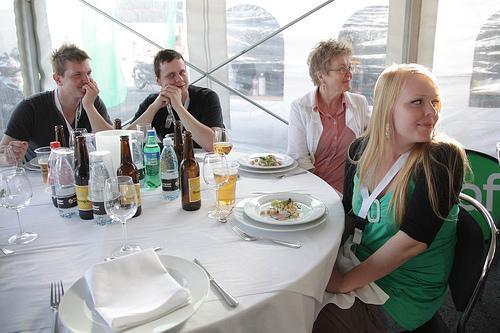How many people are in the picture?
Give a very brief answer. 4. 